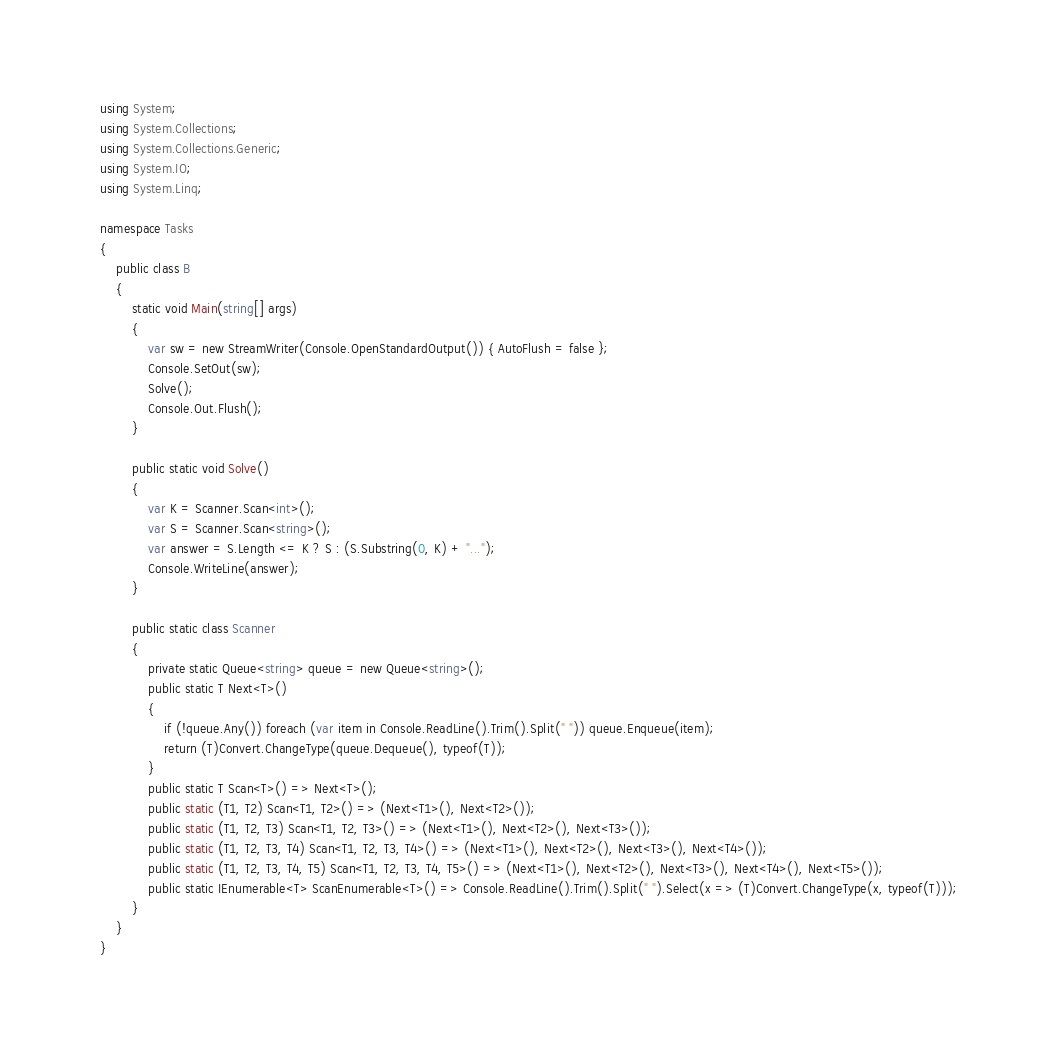<code> <loc_0><loc_0><loc_500><loc_500><_C#_>using System;
using System.Collections;
using System.Collections.Generic;
using System.IO;
using System.Linq;

namespace Tasks
{
    public class B
    {
        static void Main(string[] args)
        {
            var sw = new StreamWriter(Console.OpenStandardOutput()) { AutoFlush = false };
            Console.SetOut(sw);
            Solve();
            Console.Out.Flush();
        }

        public static void Solve()
        {
            var K = Scanner.Scan<int>();
            var S = Scanner.Scan<string>();
            var answer = S.Length <= K ? S : (S.Substring(0, K) + "...");
            Console.WriteLine(answer);
        }

        public static class Scanner
        {
            private static Queue<string> queue = new Queue<string>();
            public static T Next<T>()
            {
                if (!queue.Any()) foreach (var item in Console.ReadLine().Trim().Split(" ")) queue.Enqueue(item);
                return (T)Convert.ChangeType(queue.Dequeue(), typeof(T));
            }
            public static T Scan<T>() => Next<T>();
            public static (T1, T2) Scan<T1, T2>() => (Next<T1>(), Next<T2>());
            public static (T1, T2, T3) Scan<T1, T2, T3>() => (Next<T1>(), Next<T2>(), Next<T3>());
            public static (T1, T2, T3, T4) Scan<T1, T2, T3, T4>() => (Next<T1>(), Next<T2>(), Next<T3>(), Next<T4>());
            public static (T1, T2, T3, T4, T5) Scan<T1, T2, T3, T4, T5>() => (Next<T1>(), Next<T2>(), Next<T3>(), Next<T4>(), Next<T5>());
            public static IEnumerable<T> ScanEnumerable<T>() => Console.ReadLine().Trim().Split(" ").Select(x => (T)Convert.ChangeType(x, typeof(T)));
        }
    }
}
</code> 